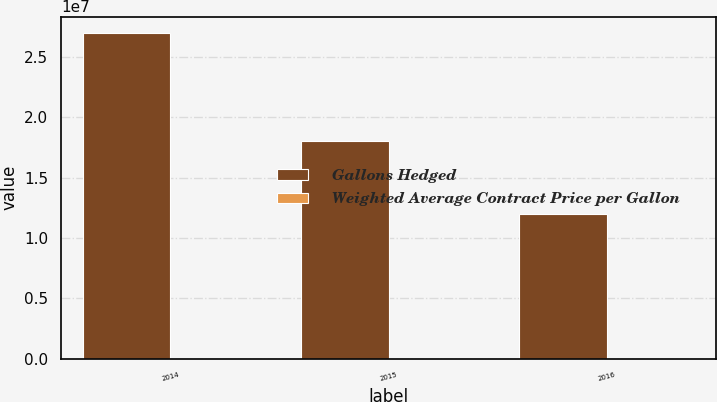Convert chart to OTSL. <chart><loc_0><loc_0><loc_500><loc_500><stacked_bar_chart><ecel><fcel>2014<fcel>2015<fcel>2016<nl><fcel>Gallons Hedged<fcel>2.7e+07<fcel>1.8e+07<fcel>1.2e+07<nl><fcel>Weighted Average Contract Price per Gallon<fcel>3.81<fcel>3.74<fcel>3.68<nl></chart> 